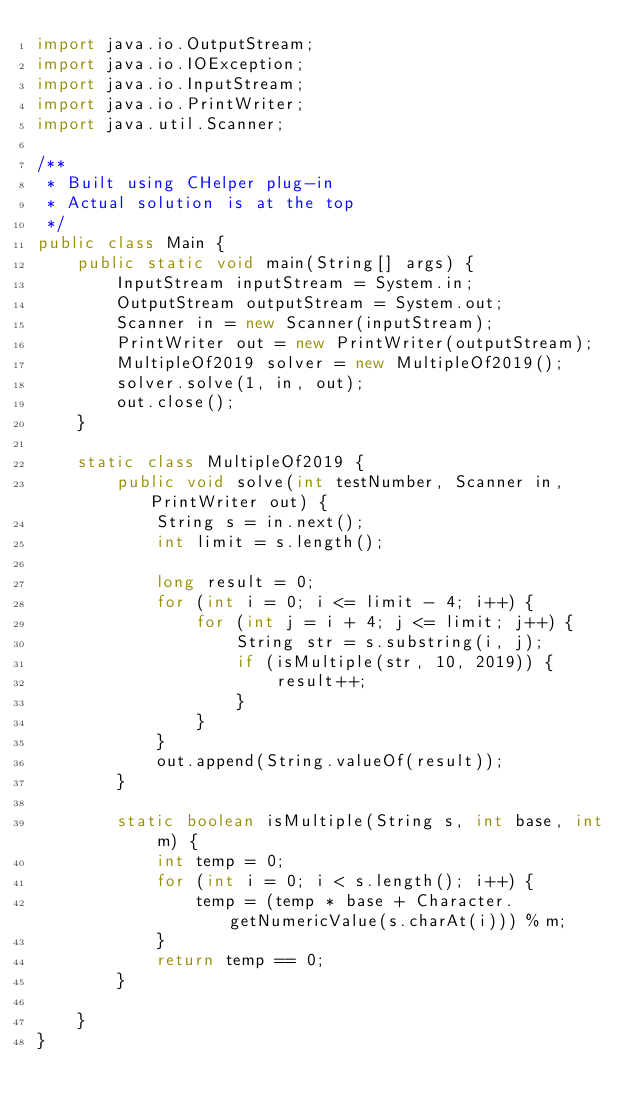Convert code to text. <code><loc_0><loc_0><loc_500><loc_500><_Java_>import java.io.OutputStream;
import java.io.IOException;
import java.io.InputStream;
import java.io.PrintWriter;
import java.util.Scanner;

/**
 * Built using CHelper plug-in
 * Actual solution is at the top
 */
public class Main {
    public static void main(String[] args) {
        InputStream inputStream = System.in;
        OutputStream outputStream = System.out;
        Scanner in = new Scanner(inputStream);
        PrintWriter out = new PrintWriter(outputStream);
        MultipleOf2019 solver = new MultipleOf2019();
        solver.solve(1, in, out);
        out.close();
    }

    static class MultipleOf2019 {
        public void solve(int testNumber, Scanner in, PrintWriter out) {
            String s = in.next();
            int limit = s.length();

            long result = 0;
            for (int i = 0; i <= limit - 4; i++) {
                for (int j = i + 4; j <= limit; j++) {
                    String str = s.substring(i, j);
                    if (isMultiple(str, 10, 2019)) {
                        result++;
                    }
                }
            }
            out.append(String.valueOf(result));
        }

        static boolean isMultiple(String s, int base, int m) {
            int temp = 0;
            for (int i = 0; i < s.length(); i++) {
                temp = (temp * base + Character.getNumericValue(s.charAt(i))) % m;
            }
            return temp == 0;
        }

    }
}

</code> 